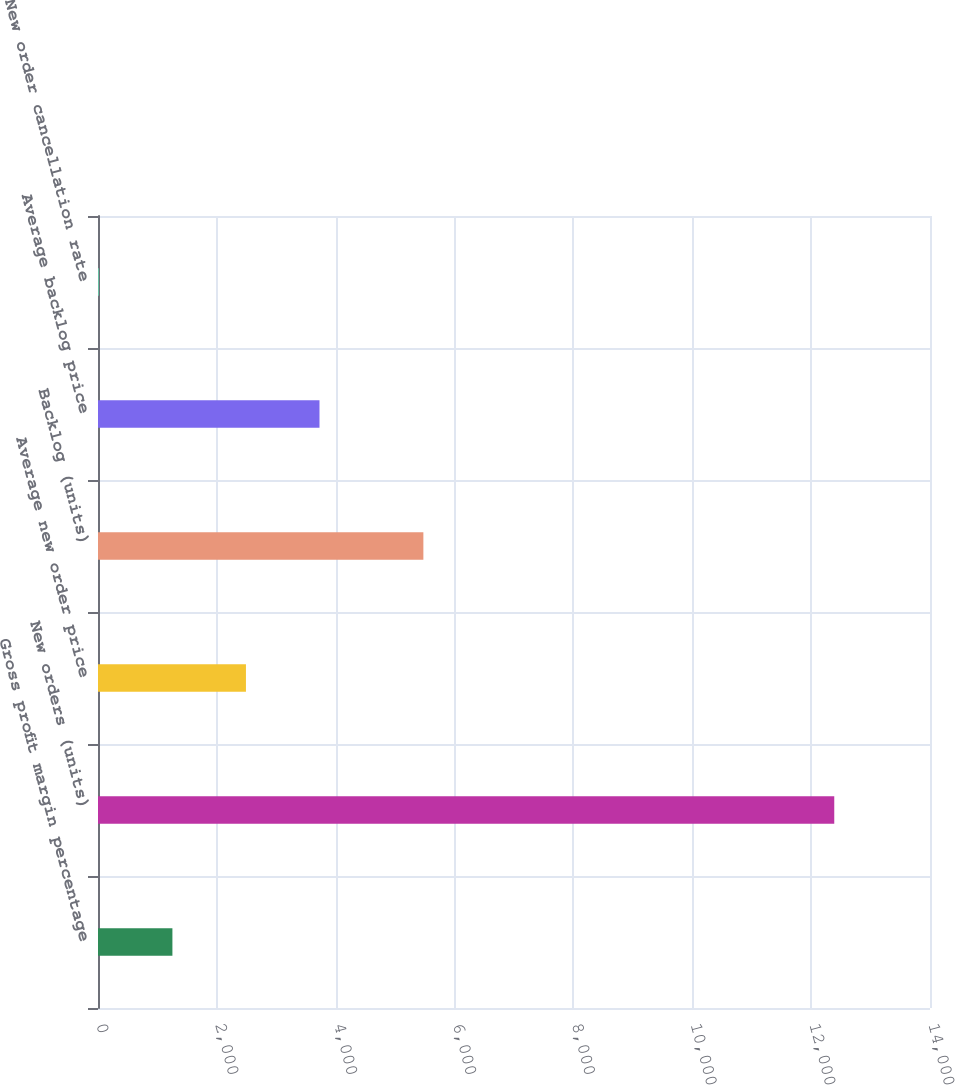Convert chart. <chart><loc_0><loc_0><loc_500><loc_500><bar_chart><fcel>Gross profit margin percentage<fcel>New orders (units)<fcel>Average new order price<fcel>Backlog (units)<fcel>Average backlog price<fcel>New order cancellation rate<nl><fcel>1252.04<fcel>12389<fcel>2489.48<fcel>5475<fcel>3726.92<fcel>14.6<nl></chart> 